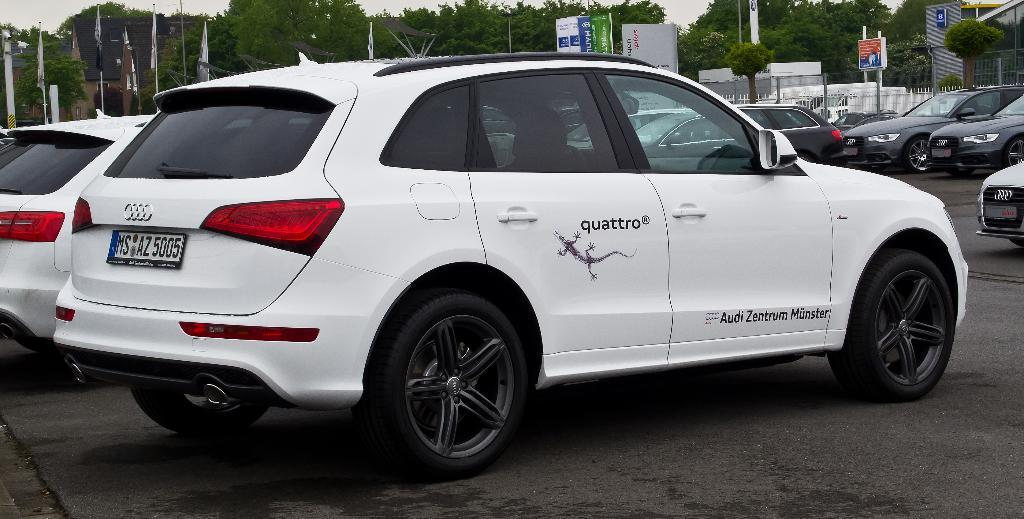What is located in the middle of the image? There are vehicles in the middle of the image. What can be seen behind the vehicles? There are poles and trees behind the vehicles. What additional elements are present in the image? There are flags and banners in the image. Where is the station located in the image? There is no station present in the image. What type of net can be seen in the image? There is no net present in the image. 